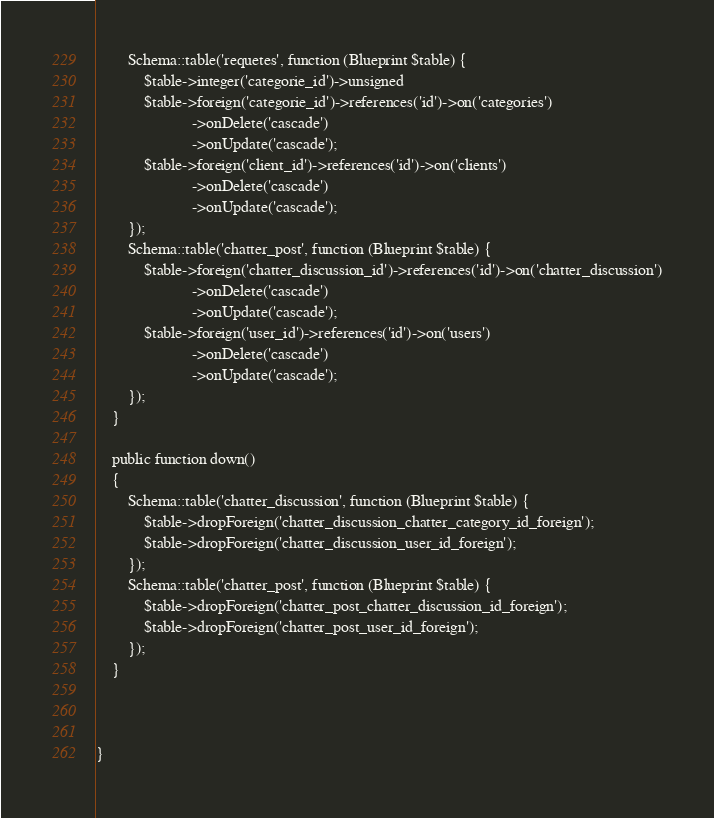<code> <loc_0><loc_0><loc_500><loc_500><_PHP_>        Schema::table('requetes', function (Blueprint $table) {
            $table->integer('categorie_id')->unsigned
            $table->foreign('categorie_id')->references('id')->on('categories')
                        ->onDelete('cascade')
                        ->onUpdate('cascade');
            $table->foreign('client_id')->references('id')->on('clients')
                        ->onDelete('cascade')
                        ->onUpdate('cascade');
        });
        Schema::table('chatter_post', function (Blueprint $table) {
            $table->foreign('chatter_discussion_id')->references('id')->on('chatter_discussion')
                        ->onDelete('cascade')
                        ->onUpdate('cascade');
            $table->foreign('user_id')->references('id')->on('users')
                        ->onDelete('cascade')
                        ->onUpdate('cascade');
        });
    }

    public function down()
    {
        Schema::table('chatter_discussion', function (Blueprint $table) {
            $table->dropForeign('chatter_discussion_chatter_category_id_foreign');
            $table->dropForeign('chatter_discussion_user_id_foreign');
        });
        Schema::table('chatter_post', function (Blueprint $table) {
            $table->dropForeign('chatter_post_chatter_discussion_id_foreign');
            $table->dropForeign('chatter_post_user_id_foreign');
        });
    }


  
}
</code> 